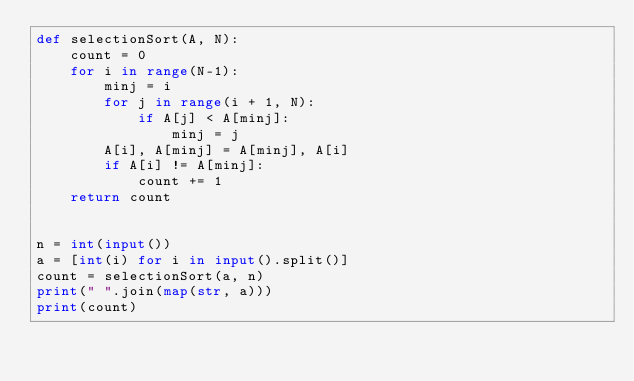<code> <loc_0><loc_0><loc_500><loc_500><_Python_>def selectionSort(A, N):
    count = 0
    for i in range(N-1):
        minj = i
        for j in range(i + 1, N):
            if A[j] < A[minj]:
                minj = j
        A[i], A[minj] = A[minj], A[i]
        if A[i] != A[minj]:
            count += 1
    return count


n = int(input())
a = [int(i) for i in input().split()]
count = selectionSort(a, n)
print(" ".join(map(str, a)))
print(count)

</code> 